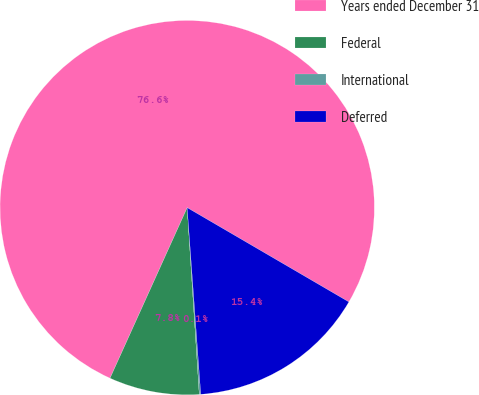Convert chart. <chart><loc_0><loc_0><loc_500><loc_500><pie_chart><fcel>Years ended December 31<fcel>Federal<fcel>International<fcel>Deferred<nl><fcel>76.64%<fcel>7.79%<fcel>0.13%<fcel>15.44%<nl></chart> 